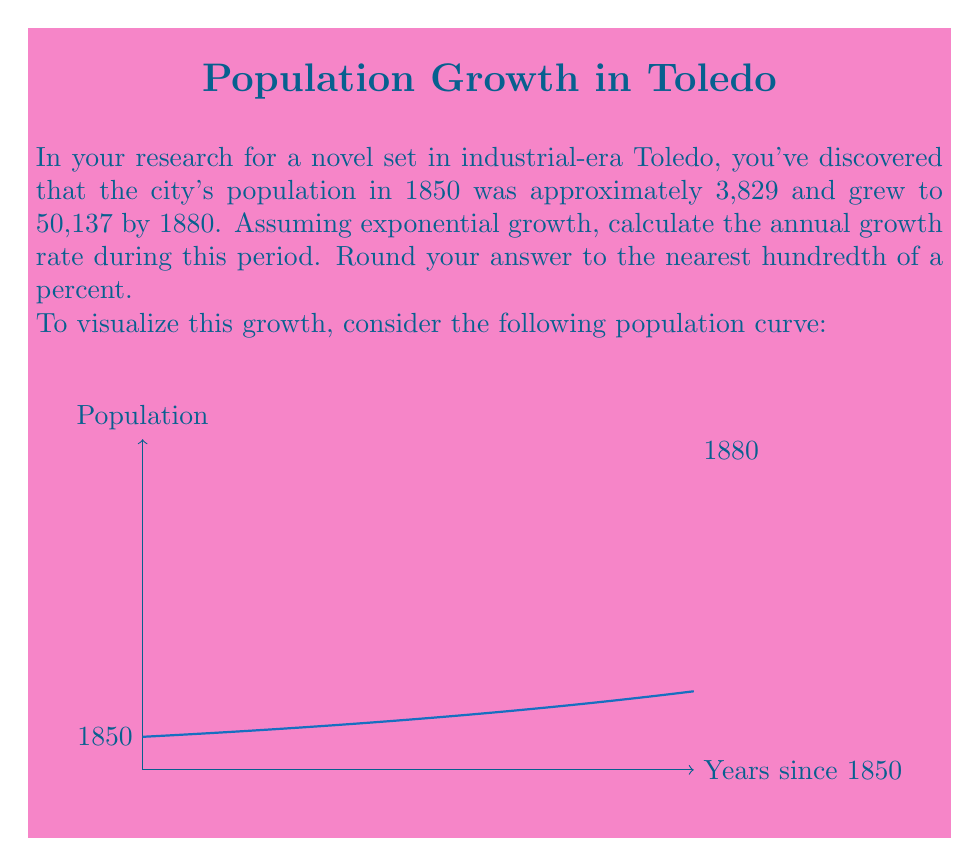Give your solution to this math problem. To solve this problem, we'll use the exponential growth formula:

$$P(t) = P_0 e^{rt}$$

Where:
$P(t)$ is the population at time $t$
$P_0$ is the initial population
$r$ is the annual growth rate
$t$ is the time in years

We know:
$P_0 = 3,829$ (population in 1850)
$P(30) = 50,137$ (population in 1880)
$t = 30$ years

Let's substitute these values into the formula:

$$50,137 = 3,829 e^{30r}$$

Now, we need to solve for $r$:

1) Divide both sides by 3,829:
   $$\frac{50,137}{3,829} = e^{30r}$$

2) Take the natural logarithm of both sides:
   $$\ln(\frac{50,137}{3,829}) = 30r$$

3) Solve for $r$:
   $$r = \frac{\ln(\frac{50,137}{3,829})}{30}$$

4) Calculate the value:
   $$r = \frac{\ln(13.0940)}{30} = \frac{2.5721}{30} = 0.08574$$

5) Convert to a percentage and round to the nearest hundredth:
   $$r \approx 8.57\%$$

Therefore, the annual growth rate was approximately 8.57%.
Answer: 8.57% 